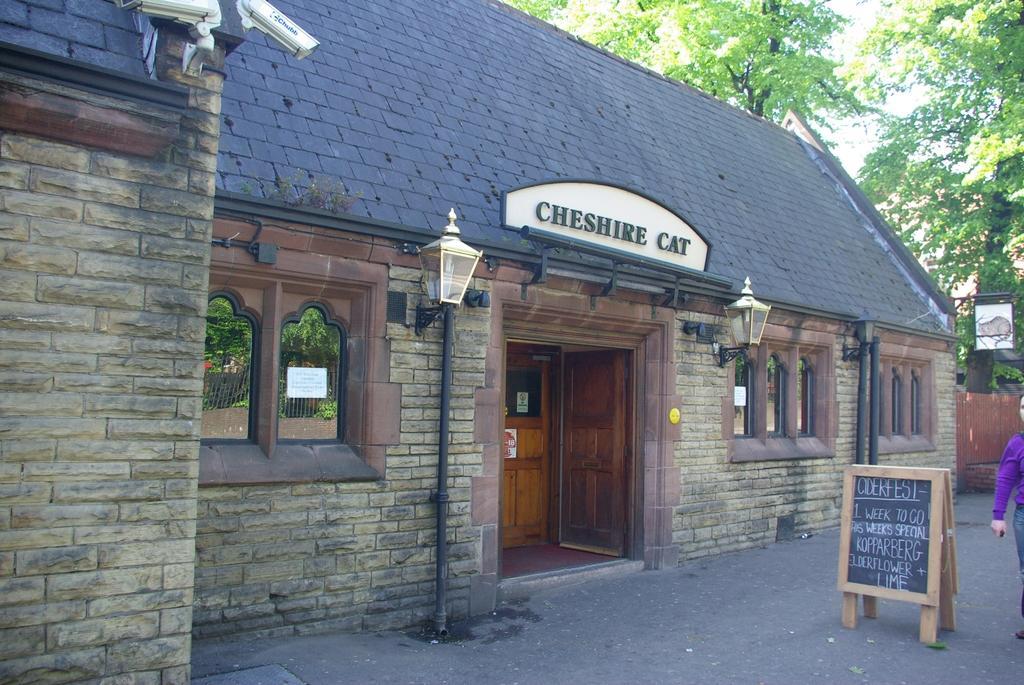Please provide a concise description of this image. In this image we can see a house with a roof, windows, street lamps, a signboard, CCTV cameras and a door. We can also see a paper pasted on a window, a board on the road with some text on it and a person standing. On the backside we can see some trees and a fence. 